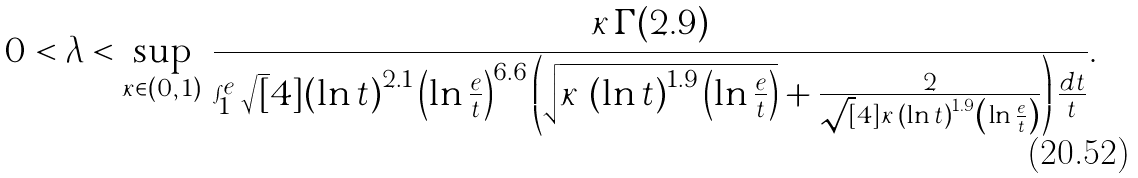<formula> <loc_0><loc_0><loc_500><loc_500>0 < \lambda < \sup _ { \kappa \in ( 0 , \, 1 ) } \, \frac { \kappa \, \Gamma ( 2 . 9 ) } { \int _ { 1 } ^ { e } \sqrt { [ } 4 ] { \left ( \ln t \right ) ^ { 2 . 1 } \left ( \ln \frac { e } { t } \right ) ^ { 6 . 6 } } \left ( \sqrt { \kappa \, \left ( \ln t \right ) ^ { 1 . 9 } \left ( \ln \frac { e } { t } \right ) } + \frac { 2 } { \sqrt { [ } 4 ] { \kappa \, \left ( \ln t \right ) ^ { 1 . 9 } \left ( \ln \frac { e } { t } \right ) } } \right ) \frac { d t } { t } } .</formula> 